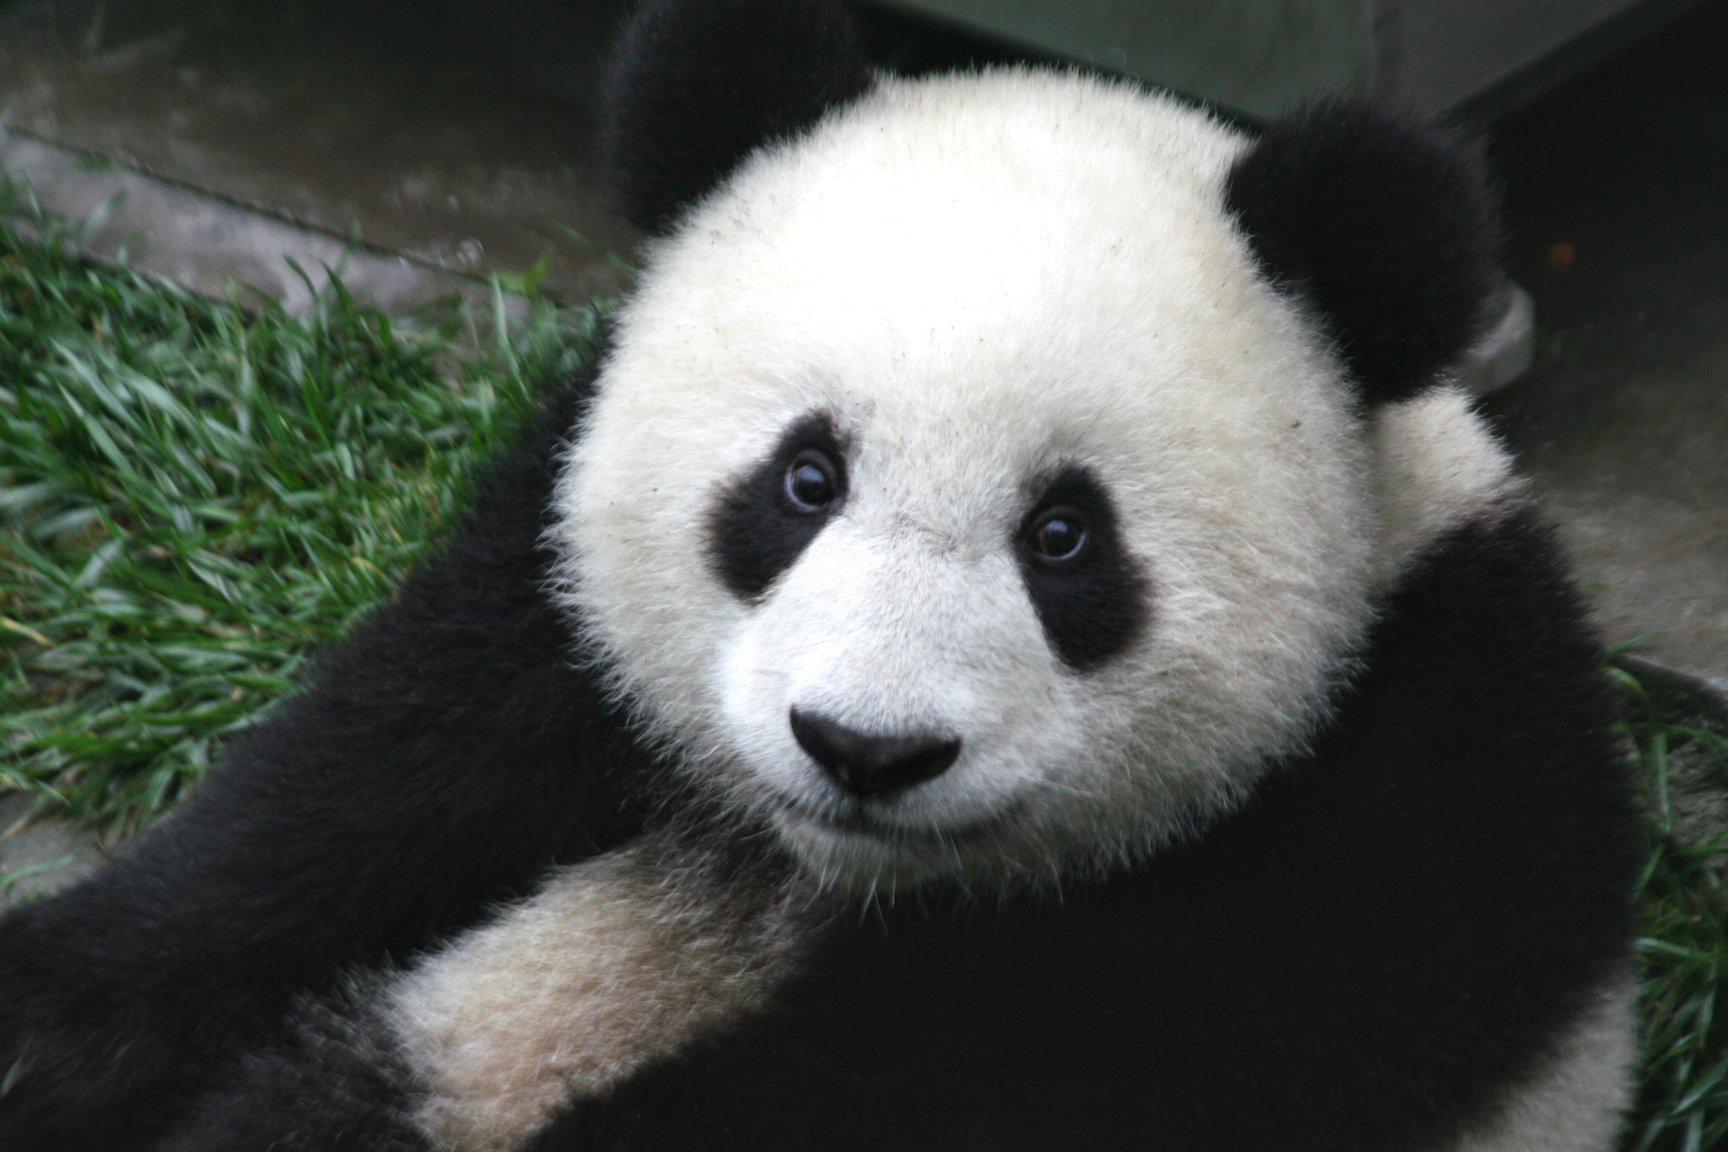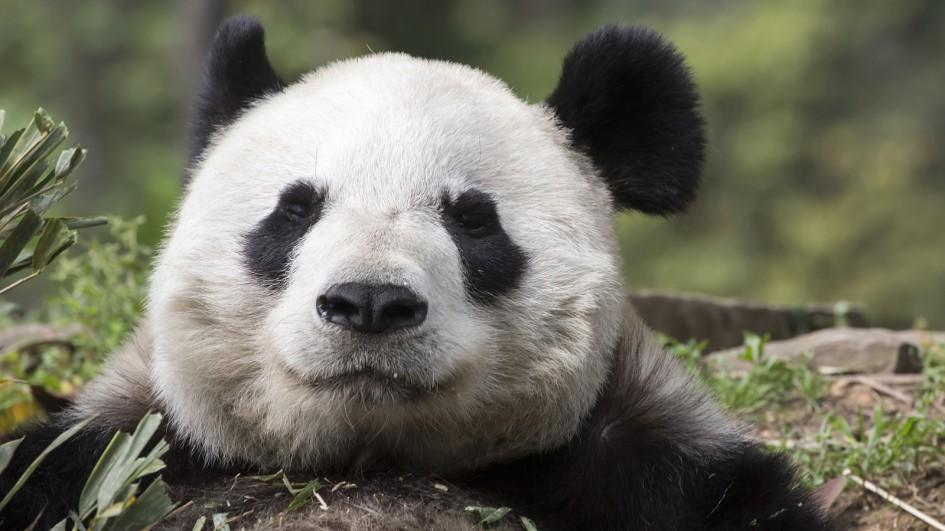The first image is the image on the left, the second image is the image on the right. Evaluate the accuracy of this statement regarding the images: "One image contains twice as many panda bears as the other image.". Is it true? Answer yes or no. No. The first image is the image on the left, the second image is the image on the right. Analyze the images presented: Is the assertion "Two pandas are in a grassy area in the image on the left." valid? Answer yes or no. No. 